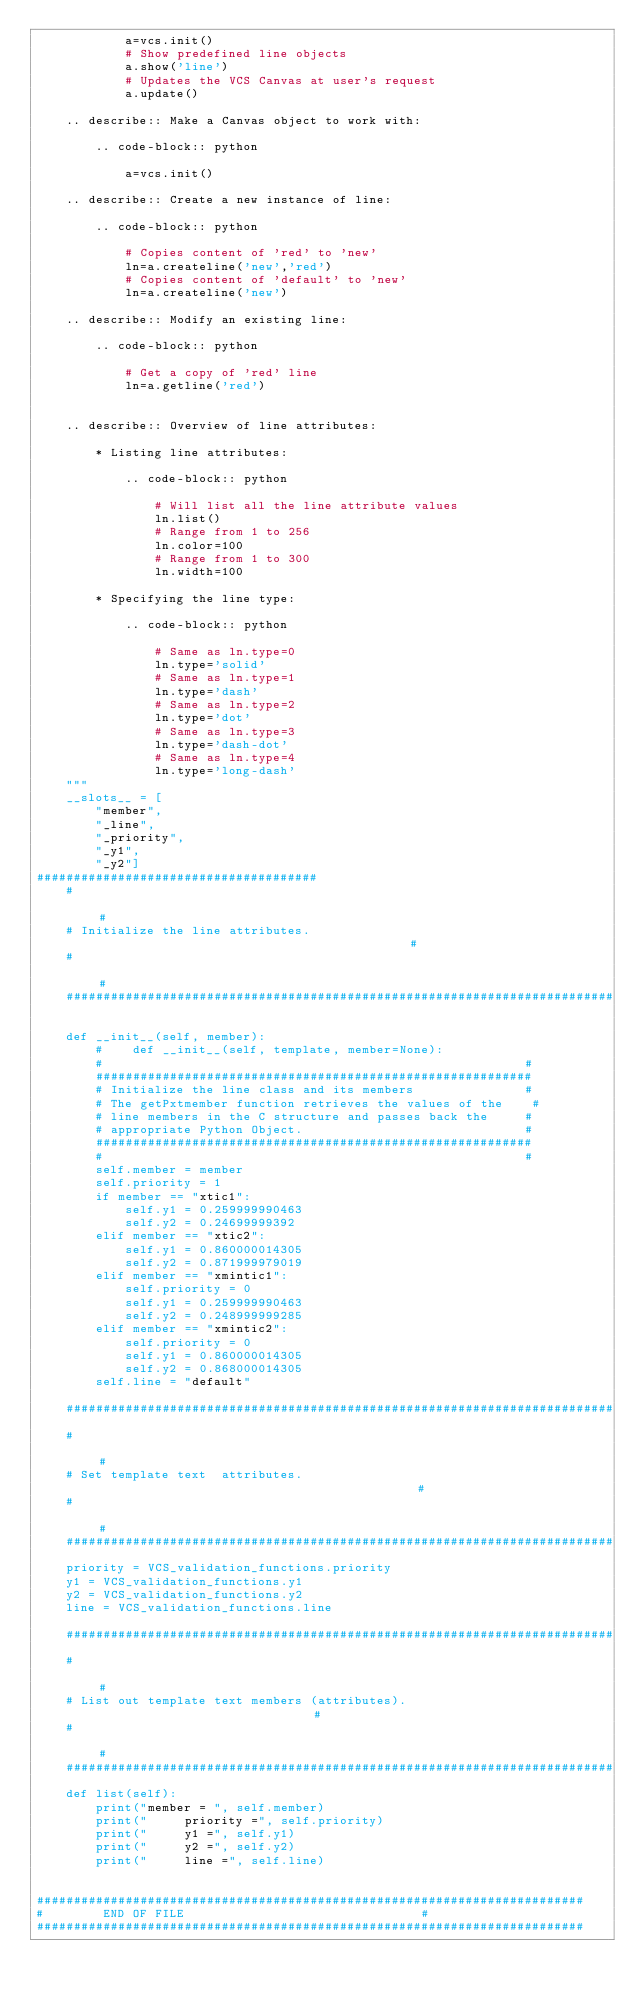Convert code to text. <code><loc_0><loc_0><loc_500><loc_500><_Python_>            a=vcs.init()
            # Show predefined line objects
            a.show('line')
            # Updates the VCS Canvas at user's request
            a.update()

    .. describe:: Make a Canvas object to work with:

        .. code-block:: python

            a=vcs.init()

    .. describe:: Create a new instance of line:

        .. code-block:: python

            # Copies content of 'red' to 'new'
            ln=a.createline('new','red')
            # Copies content of 'default' to 'new'
            ln=a.createline('new')

    .. describe:: Modify an existing line:

        .. code-block:: python

            # Get a copy of 'red' line
            ln=a.getline('red')


    .. describe:: Overview of line attributes:

        * Listing line attributes:

            .. code-block:: python

                # Will list all the line attribute values
                ln.list()
                # Range from 1 to 256
                ln.color=100
                # Range from 1 to 300
                ln.width=100

        * Specifying the line type:

            .. code-block:: python

                # Same as ln.type=0
                ln.type='solid'
                # Same as ln.type=1
                ln.type='dash'
                # Same as ln.type=2
                ln.type='dot'
                # Same as ln.type=3
                ln.type='dash-dot'
                # Same as ln.type=4
                ln.type='long-dash'
    """
    __slots__ = [
        "member",
        "_line",
        "_priority",
        "_y1",
        "_y2"]
######################################
    #                                                                           #
    # Initialize the line attributes.                                           #
    #                                                                           #
    ##########################################################################

    def __init__(self, member):
        #    def __init__(self, template, member=None):
        #                                                         #
        ###########################################################
        # Initialize the line class and its members               #
        # The getPxtmember function retrieves the values of the    #
        # line members in the C structure and passes back the     #
        # appropriate Python Object.                              #
        ###########################################################
        #                                                         #
        self.member = member
        self.priority = 1
        if member == "xtic1":
            self.y1 = 0.259999990463
            self.y2 = 0.24699999392
        elif member == "xtic2":
            self.y1 = 0.860000014305
            self.y2 = 0.871999979019
        elif member == "xmintic1":
            self.priority = 0
            self.y1 = 0.259999990463
            self.y2 = 0.248999999285
        elif member == "xmintic2":
            self.priority = 0
            self.y1 = 0.860000014305
            self.y2 = 0.868000014305
        self.line = "default"

    ##########################################################################
    #                                                                           #
    # Set template text  attributes.                                            #
    #                                                                           #
    ##########################################################################
    priority = VCS_validation_functions.priority
    y1 = VCS_validation_functions.y1
    y2 = VCS_validation_functions.y2
    line = VCS_validation_functions.line

    ##########################################################################
    #                                                                           #
    # List out template text members (attributes).                              #
    #                                                                           #
    ##########################################################################
    def list(self):
        print("member = ", self.member)
        print("     priority =", self.priority)
        print("     y1 =", self.y1)
        print("     y2 =", self.y2)
        print("     line =", self.line)


##########################################################################
#        END OF FILE								#
##########################################################################
</code> 